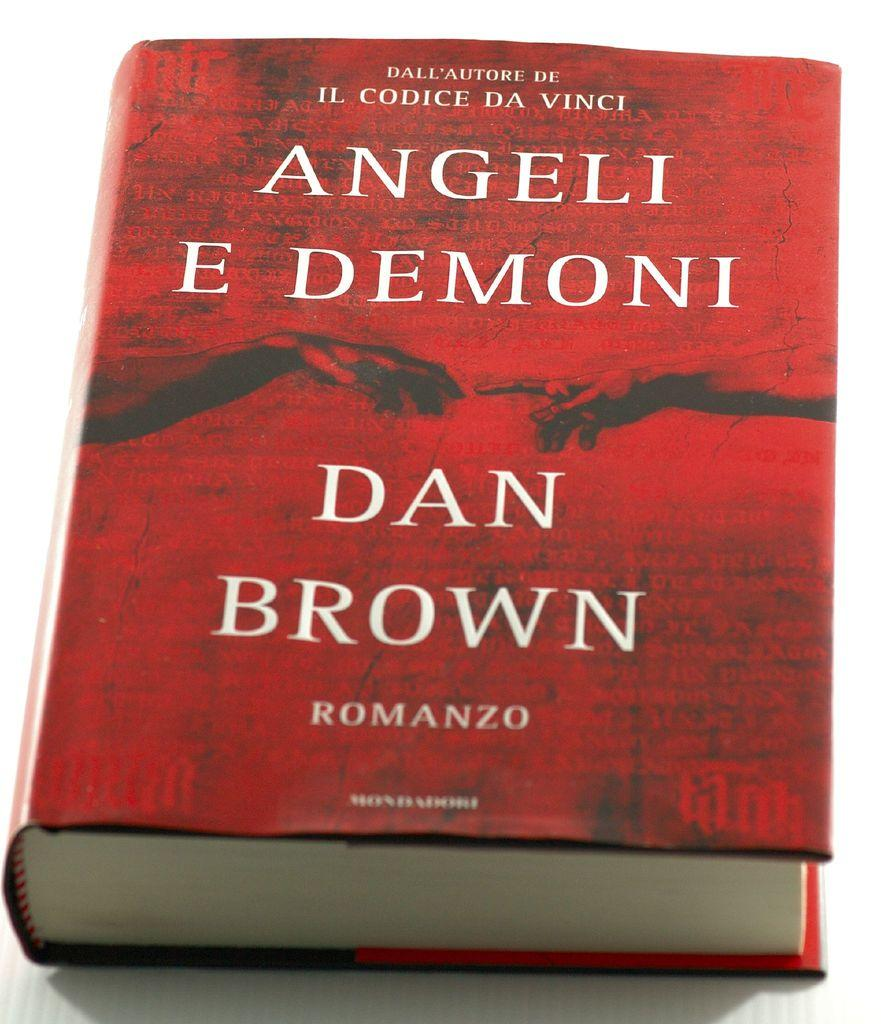<image>
Describe the image concisely. The cover of Angeli E Demoni by Dan Brown is red and shows to people's hands reaching towards each other. 